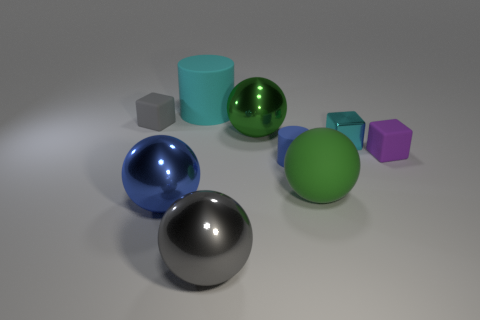What number of other things are the same color as the tiny metallic cube?
Give a very brief answer. 1. Is the color of the matte ball the same as the metallic block?
Offer a terse response. No. There is a blue metallic thing that is the same shape as the big gray shiny object; what size is it?
Your answer should be very brief. Large. How many tiny purple spheres have the same material as the blue cylinder?
Provide a short and direct response. 0. Do the small cube that is to the left of the large green shiny ball and the big gray object have the same material?
Ensure brevity in your answer.  No. Are there an equal number of small rubber blocks that are left of the green matte ball and yellow spheres?
Offer a terse response. No. What size is the green rubber ball?
Your response must be concise. Large. There is a big ball that is the same color as the tiny matte cylinder; what material is it?
Provide a short and direct response. Metal. How many large balls have the same color as the big matte cylinder?
Offer a terse response. 0. Do the gray metallic object and the blue rubber cylinder have the same size?
Your answer should be compact. No. 